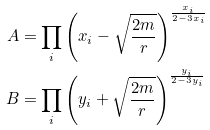<formula> <loc_0><loc_0><loc_500><loc_500>A & = \prod _ { i } \left ( x _ { i } - \sqrt { \frac { 2 m } { r } } \right ) ^ { \frac { x _ { i } } { 2 - 3 x _ { i } } } \\ B & = \prod _ { i } \left ( y _ { i } + \sqrt { \frac { 2 m } { r } } \right ) ^ { \frac { y _ { i } } { 2 - 3 y _ { i } } }</formula> 